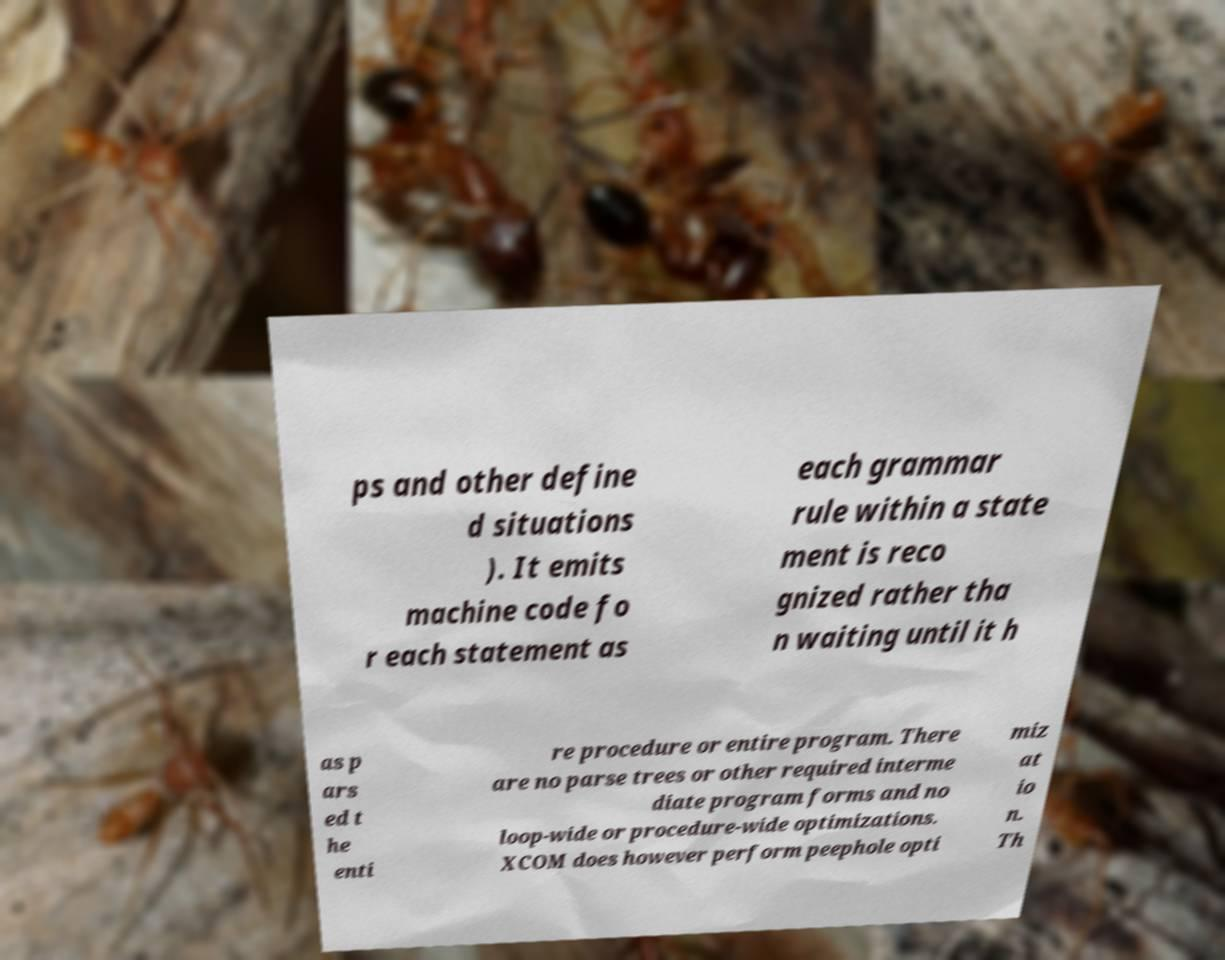For documentation purposes, I need the text within this image transcribed. Could you provide that? ps and other define d situations ). It emits machine code fo r each statement as each grammar rule within a state ment is reco gnized rather tha n waiting until it h as p ars ed t he enti re procedure or entire program. There are no parse trees or other required interme diate program forms and no loop-wide or procedure-wide optimizations. XCOM does however perform peephole opti miz at io n. Th 